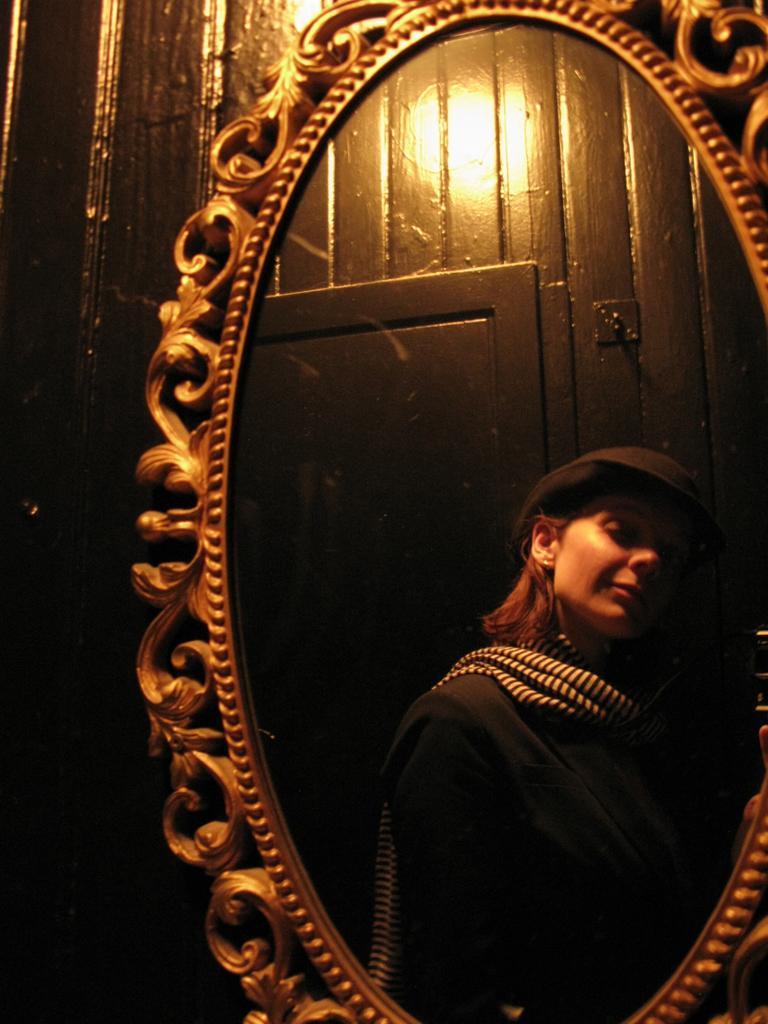Please provide a concise description of this image. A woman is wearing hat, this is mirror, this is door. 